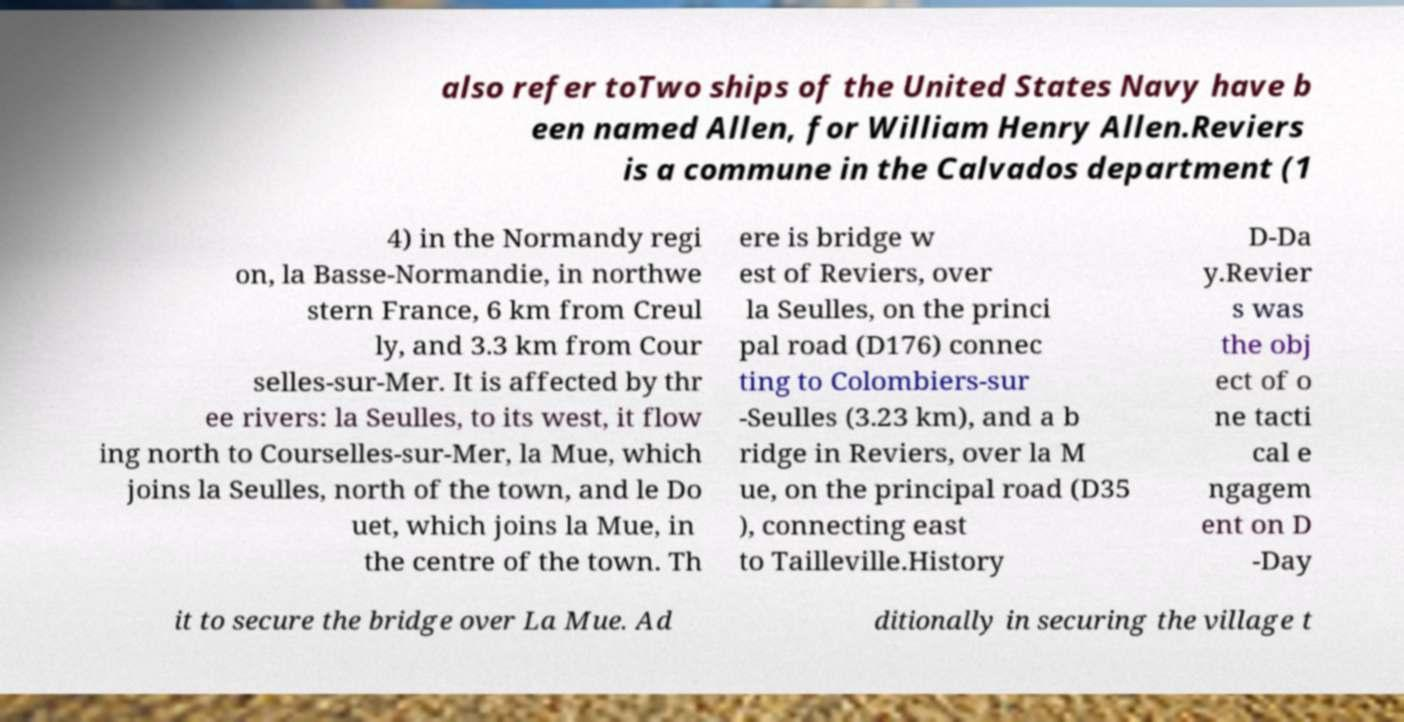I need the written content from this picture converted into text. Can you do that? also refer toTwo ships of the United States Navy have b een named Allen, for William Henry Allen.Reviers is a commune in the Calvados department (1 4) in the Normandy regi on, la Basse-Normandie, in northwe stern France, 6 km from Creul ly, and 3.3 km from Cour selles-sur-Mer. It is affected by thr ee rivers: la Seulles, to its west, it flow ing north to Courselles-sur-Mer, la Mue, which joins la Seulles, north of the town, and le Do uet, which joins la Mue, in the centre of the town. Th ere is bridge w est of Reviers, over la Seulles, on the princi pal road (D176) connec ting to Colombiers-sur -Seulles (3.23 km), and a b ridge in Reviers, over la M ue, on the principal road (D35 ), connecting east to Tailleville.History D-Da y.Revier s was the obj ect of o ne tacti cal e ngagem ent on D -Day it to secure the bridge over La Mue. Ad ditionally in securing the village t 